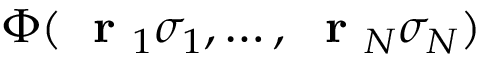Convert formula to latex. <formula><loc_0><loc_0><loc_500><loc_500>\Phi ( r _ { 1 } \sigma _ { 1 } , \dots , r _ { N } \sigma _ { N } )</formula> 